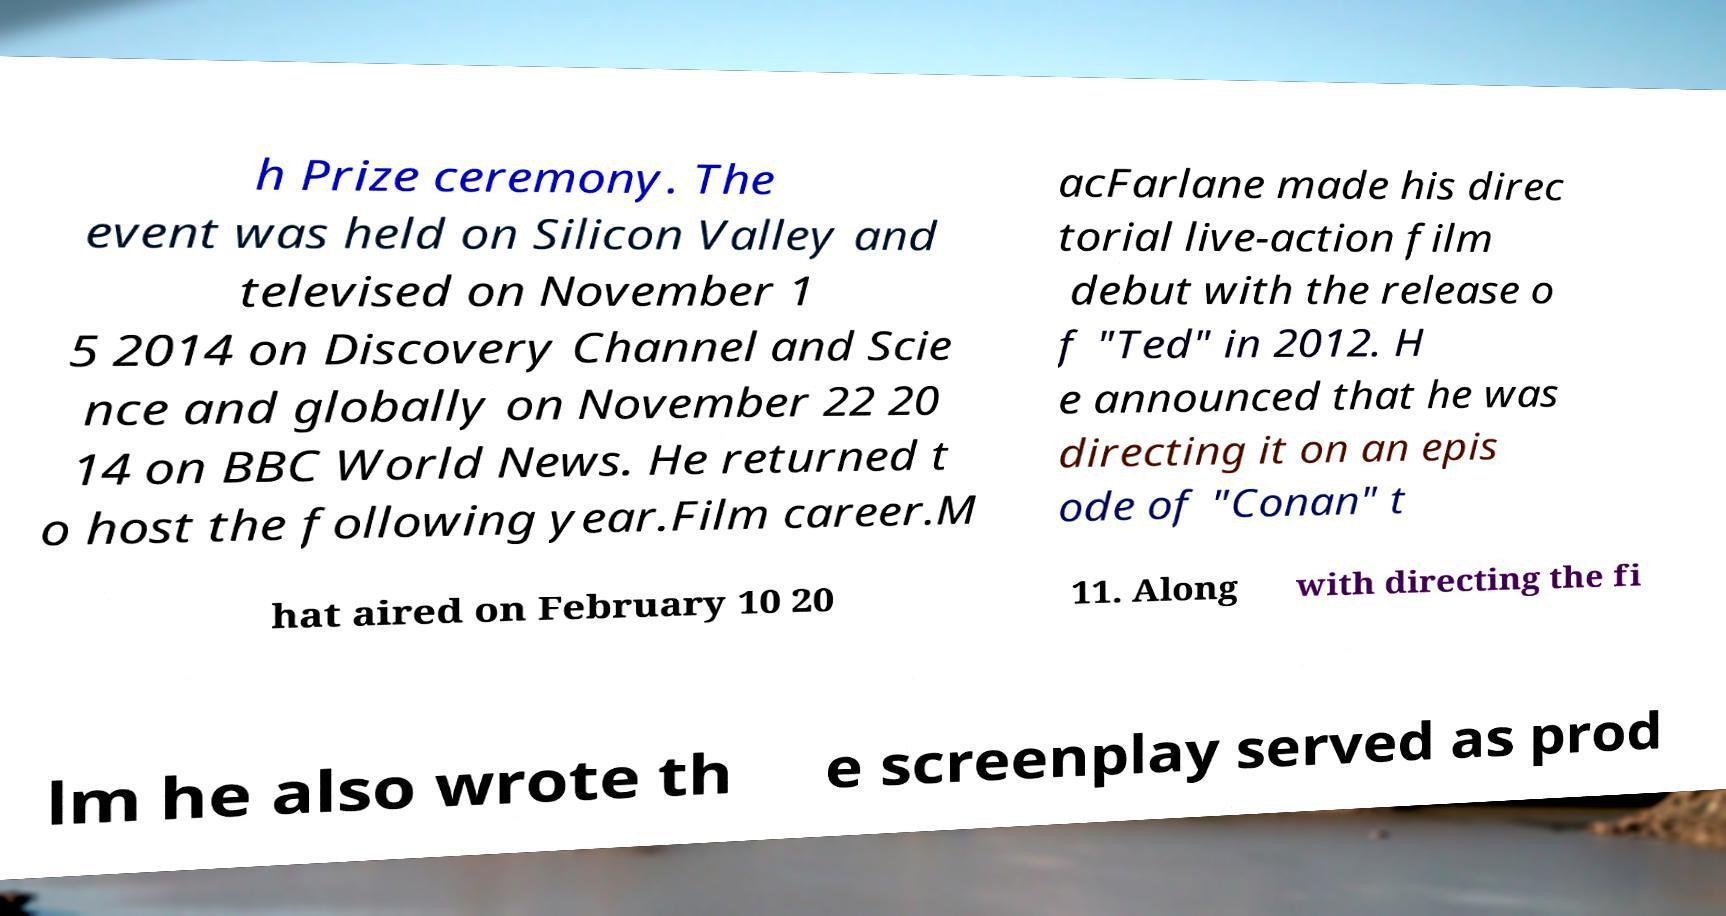There's text embedded in this image that I need extracted. Can you transcribe it verbatim? h Prize ceremony. The event was held on Silicon Valley and televised on November 1 5 2014 on Discovery Channel and Scie nce and globally on November 22 20 14 on BBC World News. He returned t o host the following year.Film career.M acFarlane made his direc torial live-action film debut with the release o f "Ted" in 2012. H e announced that he was directing it on an epis ode of "Conan" t hat aired on February 10 20 11. Along with directing the fi lm he also wrote th e screenplay served as prod 